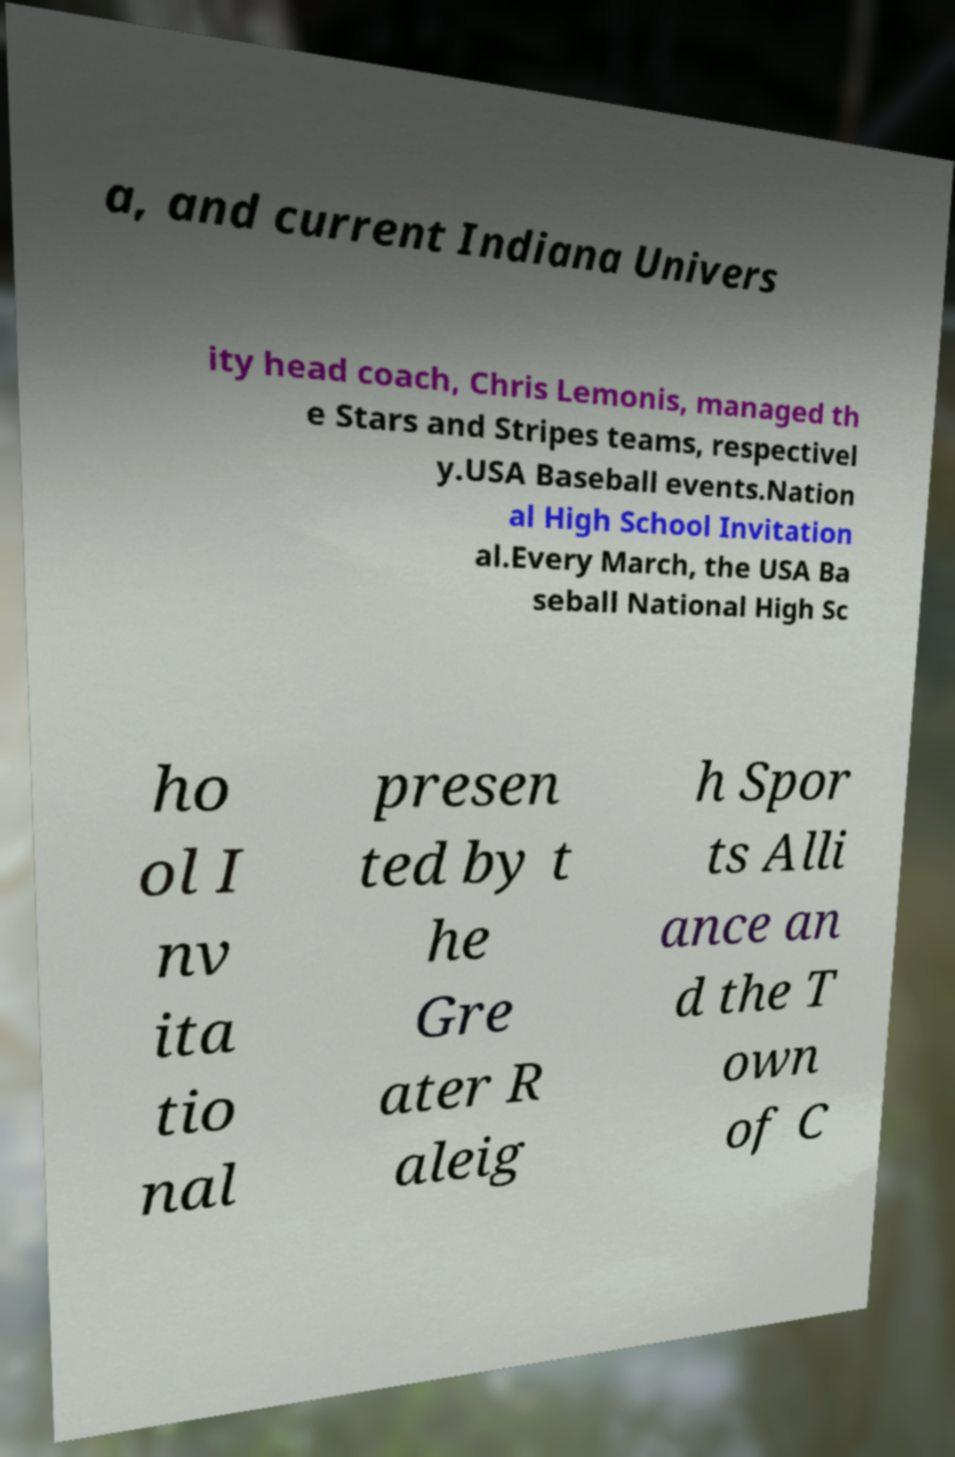What messages or text are displayed in this image? I need them in a readable, typed format. a, and current Indiana Univers ity head coach, Chris Lemonis, managed th e Stars and Stripes teams, respectivel y.USA Baseball events.Nation al High School Invitation al.Every March, the USA Ba seball National High Sc ho ol I nv ita tio nal presen ted by t he Gre ater R aleig h Spor ts Alli ance an d the T own of C 